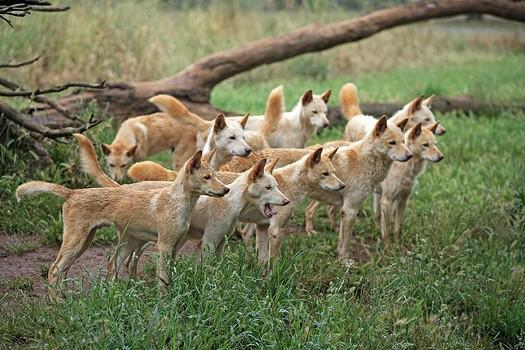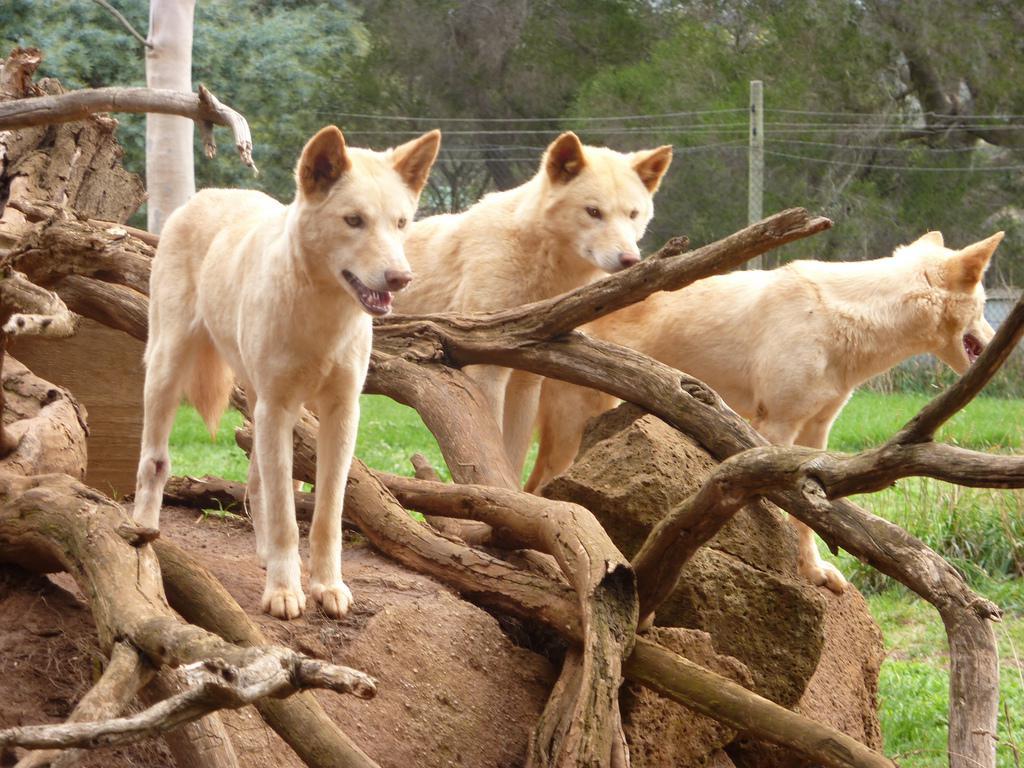The first image is the image on the left, the second image is the image on the right. Analyze the images presented: Is the assertion "The left image contains exactly two canines." valid? Answer yes or no. No. The first image is the image on the left, the second image is the image on the right. Analyze the images presented: Is the assertion "There are exactly three canines in the right image." valid? Answer yes or no. Yes. 